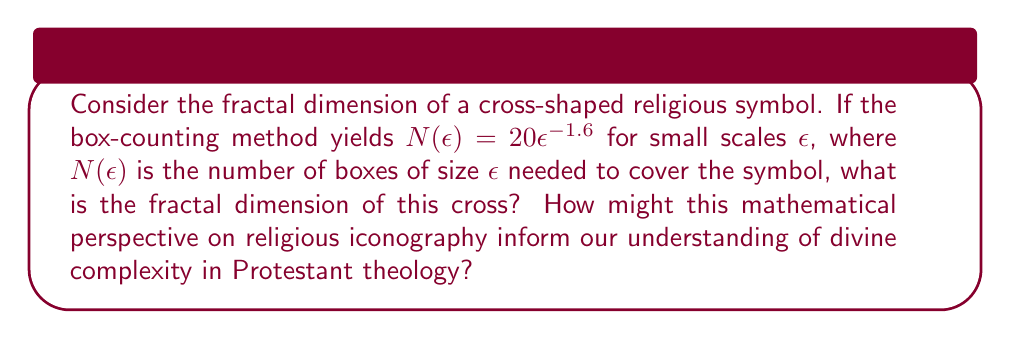Show me your answer to this math problem. To solve this problem, we'll use the box-counting method to determine the fractal dimension:

1) The general form of the box-counting relationship is:

   $$N(\epsilon) = k\epsilon^{-D}$$

   where $D$ is the fractal dimension we're seeking.

2) In our case, we're given:

   $$N(\epsilon) = 20\epsilon^{-1.6}$$

3) Comparing these two equations, we can see that:

   $k = 20$ and $D = 1.6$

4) Therefore, the fractal dimension of the cross symbol is 1.6.

5) Interpretation in Protestant theology:
   - The fractal dimension of 1.6 suggests a complexity between a one-dimensional line (D=1) and a two-dimensional plane (D=2).
   - This could be interpreted as representing the dual nature of Christ (human and divine) or the complexity of faith itself.
   - The non-integer dimension might also symbolize the mysterious and paradoxical aspects of divine nature, challenging our linear understanding of theology.
   - In Protestant thought, this mathematical perspective could encourage a more nuanced view of religious symbols, balancing simplicity of faith with recognition of divine complexity.
Answer: $D = 1.6$ 